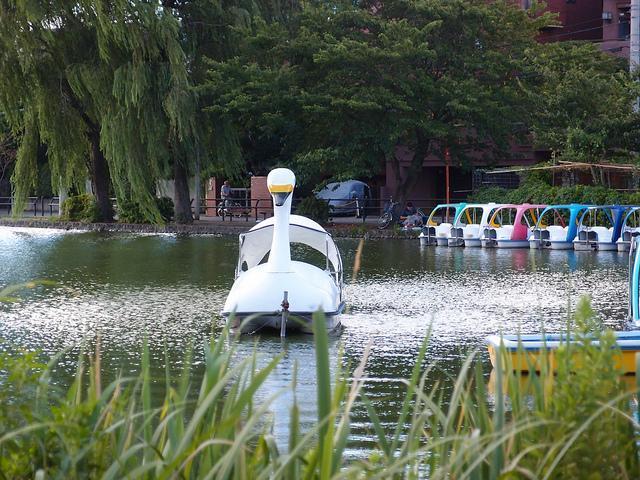How many boats can be seen?
Give a very brief answer. 4. How many airplane lights are red?
Give a very brief answer. 0. 